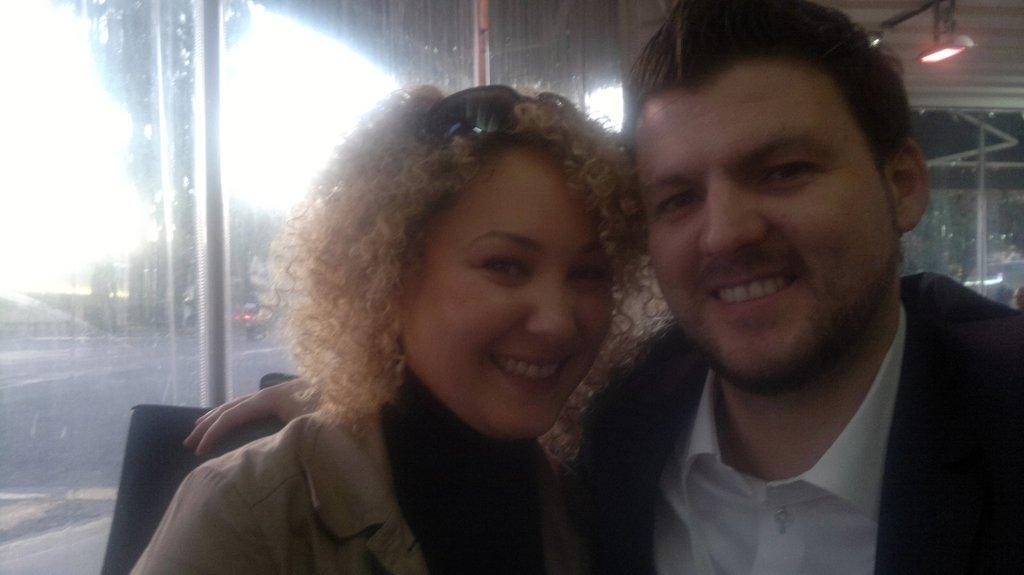How many people are present in the image? There are two persons in the image. What can be seen in the image besides the people? Lights are visible in the image. What architectural features can be seen in the image? There are windows in the image. What type of vacation is the person in the image planning? There is no indication in the image that the person is planning a vacation. How does the person's stomach look in the image? There is no visible stomach of the person in the image. What color is the person's eye in the image? There is no visible eye of the person in the image. 